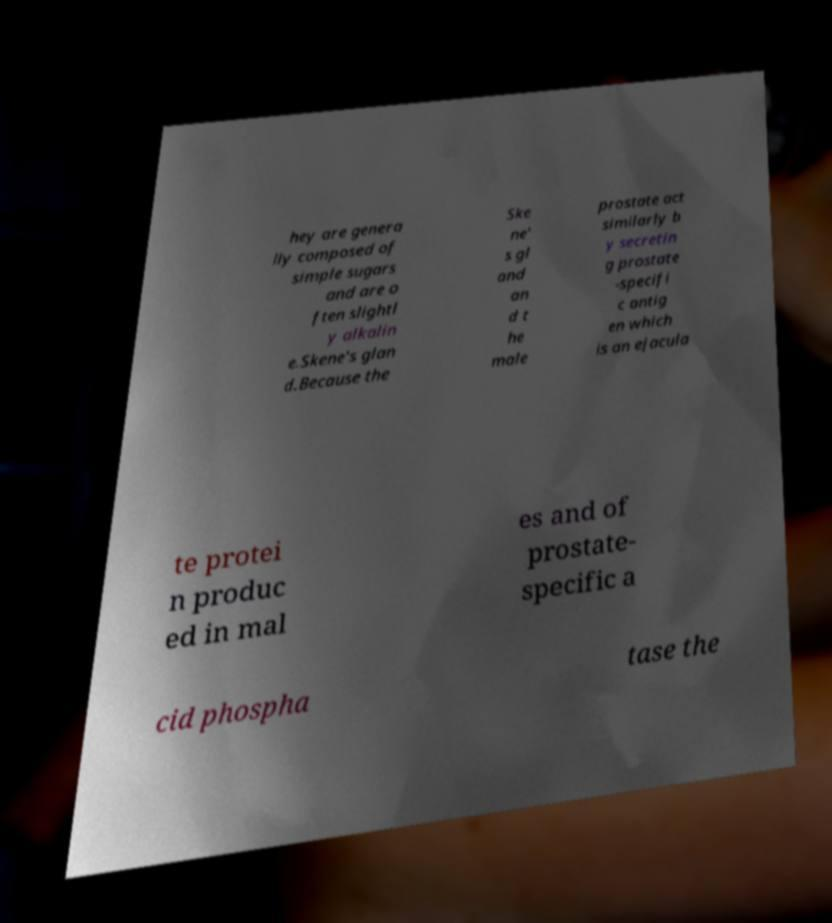Could you extract and type out the text from this image? hey are genera lly composed of simple sugars and are o ften slightl y alkalin e.Skene's glan d.Because the Ske ne' s gl and an d t he male prostate act similarly b y secretin g prostate -specifi c antig en which is an ejacula te protei n produc ed in mal es and of prostate- specific a cid phospha tase the 